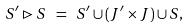<formula> <loc_0><loc_0><loc_500><loc_500>S ^ { \prime } \rhd S \ = \ S ^ { \prime } \cup ( J ^ { \prime } \times J ) \cup S ,</formula> 